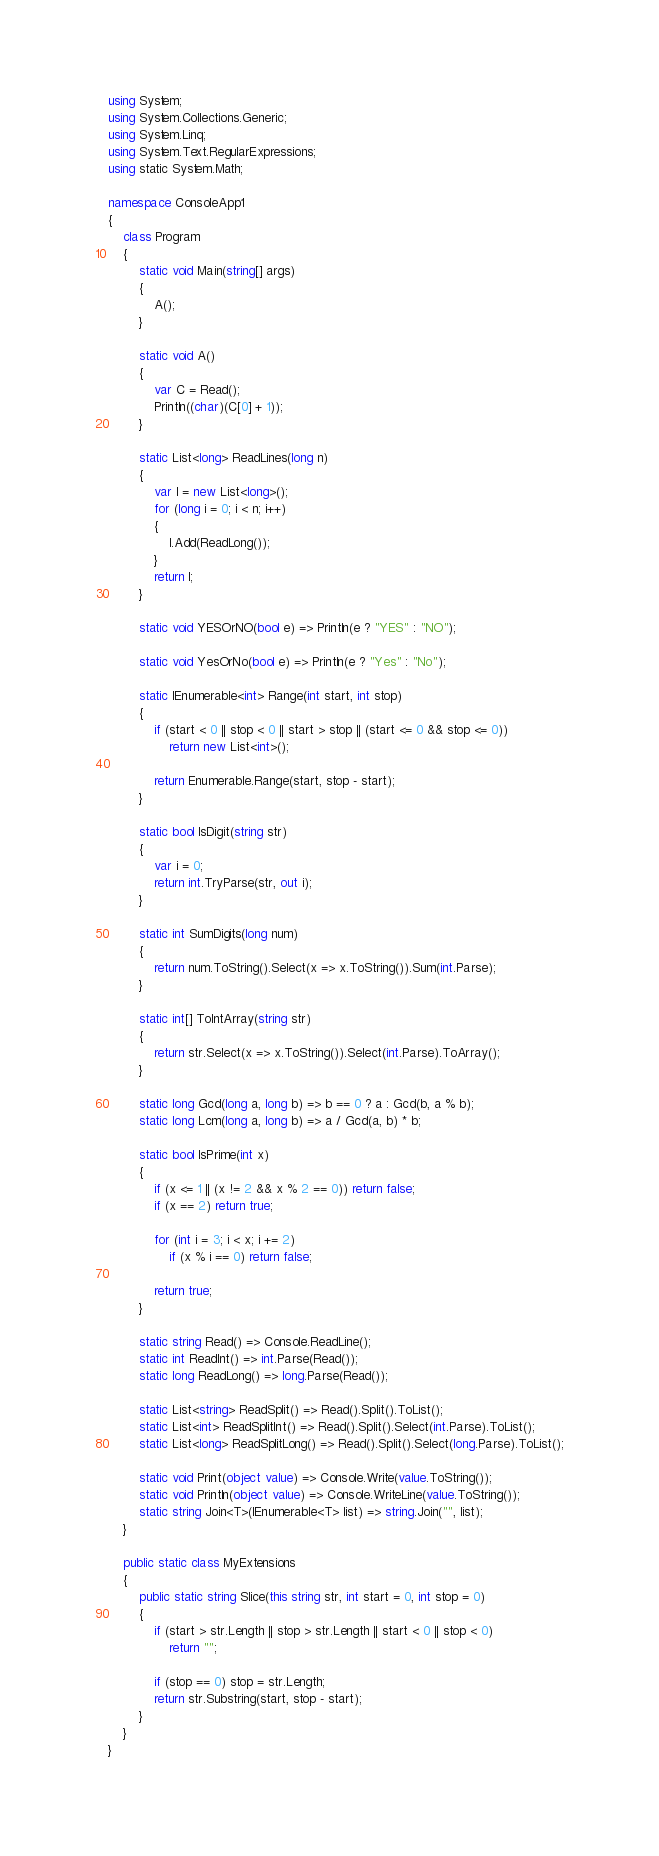Convert code to text. <code><loc_0><loc_0><loc_500><loc_500><_C#_>using System;
using System.Collections.Generic;
using System.Linq;
using System.Text.RegularExpressions;
using static System.Math;

namespace ConsoleApp1
{
    class Program
    {
        static void Main(string[] args)
        {
            A();
        }

        static void A()
        {
            var C = Read();
            Println((char)(C[0] + 1));
        }

        static List<long> ReadLines(long n)
        {
            var l = new List<long>();
            for (long i = 0; i < n; i++)
            {
                l.Add(ReadLong());
            }
            return l;
        }

        static void YESOrNO(bool e) => Println(e ? "YES" : "NO");

        static void YesOrNo(bool e) => Println(e ? "Yes" : "No");

        static IEnumerable<int> Range(int start, int stop)
        {
            if (start < 0 || stop < 0 || start > stop || (start <= 0 && stop <= 0))
                return new List<int>();

            return Enumerable.Range(start, stop - start);
        }

        static bool IsDigit(string str)
        {
            var i = 0;
            return int.TryParse(str, out i);
        }

        static int SumDigits(long num)
        {
            return num.ToString().Select(x => x.ToString()).Sum(int.Parse);
        }

        static int[] ToIntArray(string str)
        {
            return str.Select(x => x.ToString()).Select(int.Parse).ToArray();
        }

        static long Gcd(long a, long b) => b == 0 ? a : Gcd(b, a % b);
        static long Lcm(long a, long b) => a / Gcd(a, b) * b;

        static bool IsPrime(int x)
        {
            if (x <= 1 || (x != 2 && x % 2 == 0)) return false;
            if (x == 2) return true;

            for (int i = 3; i < x; i += 2)
                if (x % i == 0) return false;

            return true;
        }

        static string Read() => Console.ReadLine();
        static int ReadInt() => int.Parse(Read());
        static long ReadLong() => long.Parse(Read());

        static List<string> ReadSplit() => Read().Split().ToList();
        static List<int> ReadSplitInt() => Read().Split().Select(int.Parse).ToList();
        static List<long> ReadSplitLong() => Read().Split().Select(long.Parse).ToList();

        static void Print(object value) => Console.Write(value.ToString());
        static void Println(object value) => Console.WriteLine(value.ToString());
        static string Join<T>(IEnumerable<T> list) => string.Join("", list);
    }

    public static class MyExtensions
    {
        public static string Slice(this string str, int start = 0, int stop = 0)
        {
            if (start > str.Length || stop > str.Length || start < 0 || stop < 0)
                return "";

            if (stop == 0) stop = str.Length;
            return str.Substring(start, stop - start);
        }
    }
}</code> 